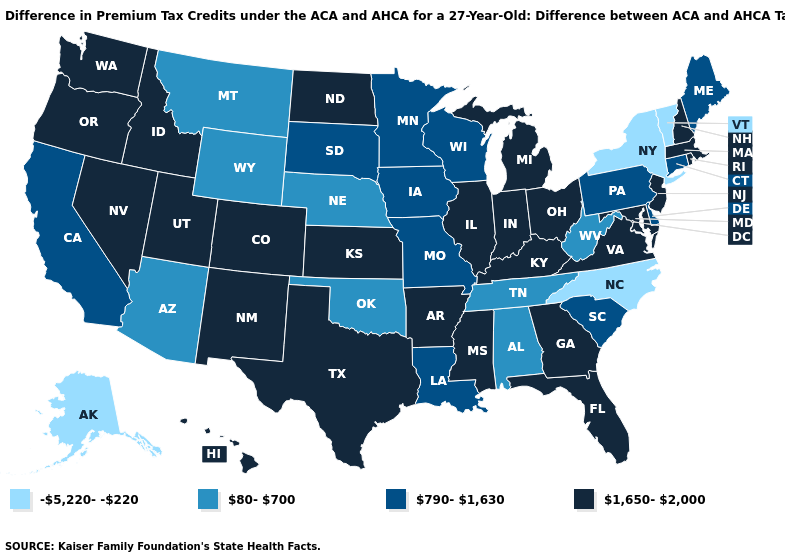Does the map have missing data?
Short answer required. No. What is the highest value in states that border Wisconsin?
Quick response, please. 1,650-2,000. Which states have the lowest value in the USA?
Write a very short answer. Alaska, New York, North Carolina, Vermont. Among the states that border Connecticut , which have the highest value?
Keep it brief. Massachusetts, Rhode Island. Does Oklahoma have the highest value in the South?
Keep it brief. No. What is the lowest value in the USA?
Quick response, please. -5,220--220. What is the value of Texas?
Concise answer only. 1,650-2,000. Does Texas have the same value as Tennessee?
Give a very brief answer. No. Does Alabama have a higher value than Minnesota?
Quick response, please. No. How many symbols are there in the legend?
Short answer required. 4. What is the highest value in states that border Mississippi?
Short answer required. 1,650-2,000. How many symbols are there in the legend?
Answer briefly. 4. What is the value of Kentucky?
Be succinct. 1,650-2,000. Name the states that have a value in the range 80-700?
Concise answer only. Alabama, Arizona, Montana, Nebraska, Oklahoma, Tennessee, West Virginia, Wyoming. 